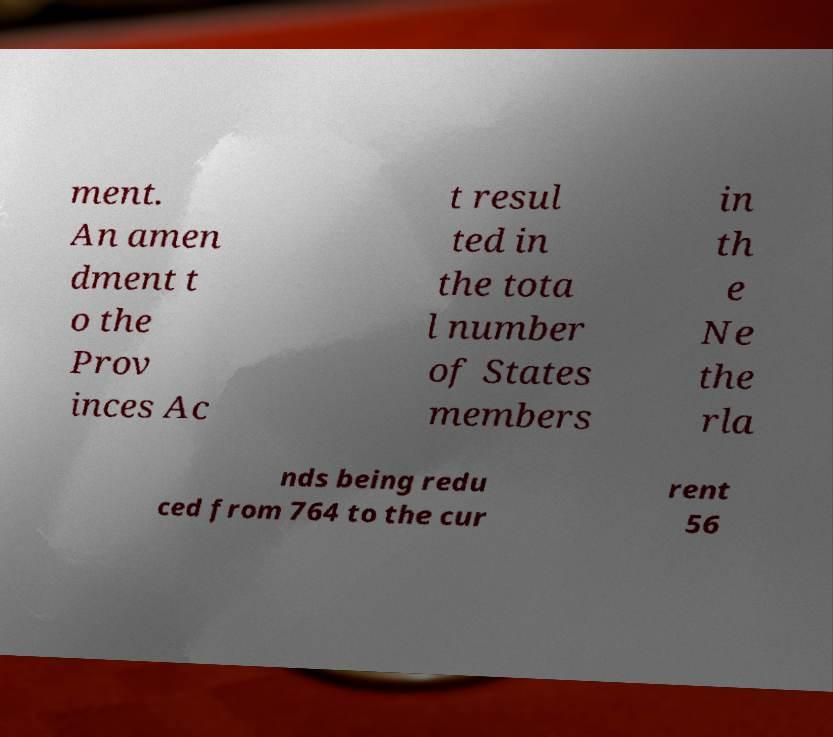Could you extract and type out the text from this image? ment. An amen dment t o the Prov inces Ac t resul ted in the tota l number of States members in th e Ne the rla nds being redu ced from 764 to the cur rent 56 